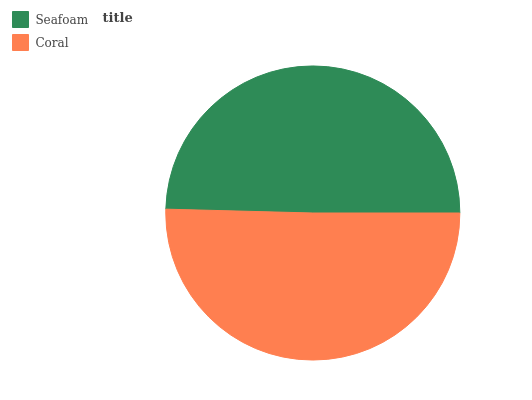Is Seafoam the minimum?
Answer yes or no. Yes. Is Coral the maximum?
Answer yes or no. Yes. Is Coral the minimum?
Answer yes or no. No. Is Coral greater than Seafoam?
Answer yes or no. Yes. Is Seafoam less than Coral?
Answer yes or no. Yes. Is Seafoam greater than Coral?
Answer yes or no. No. Is Coral less than Seafoam?
Answer yes or no. No. Is Coral the high median?
Answer yes or no. Yes. Is Seafoam the low median?
Answer yes or no. Yes. Is Seafoam the high median?
Answer yes or no. No. Is Coral the low median?
Answer yes or no. No. 